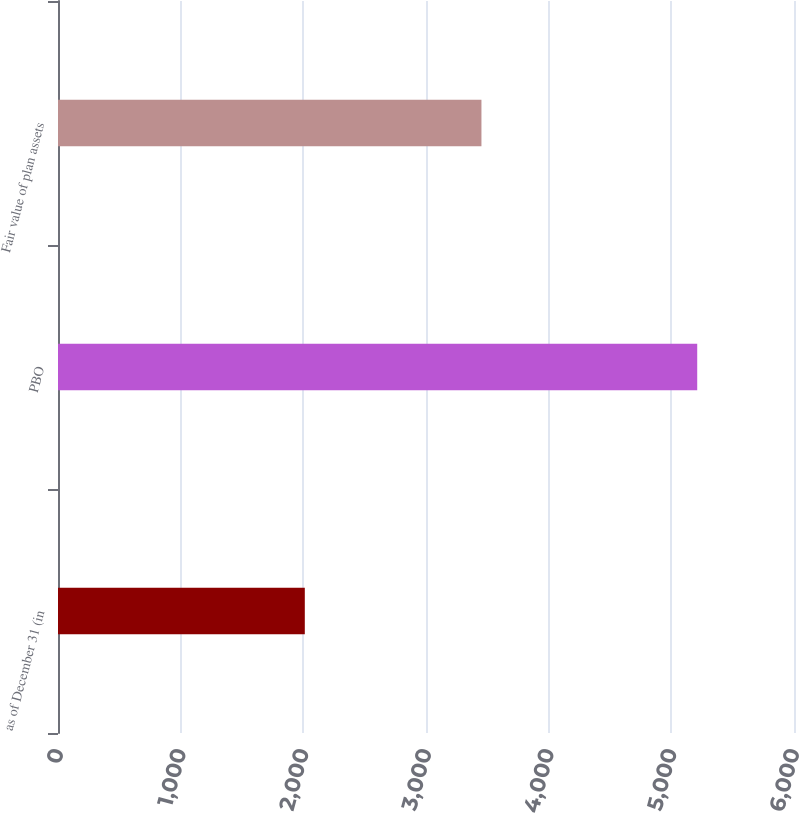Convert chart. <chart><loc_0><loc_0><loc_500><loc_500><bar_chart><fcel>as of December 31 (in<fcel>PBO<fcel>Fair value of plan assets<nl><fcel>2012<fcel>5211<fcel>3452<nl></chart> 